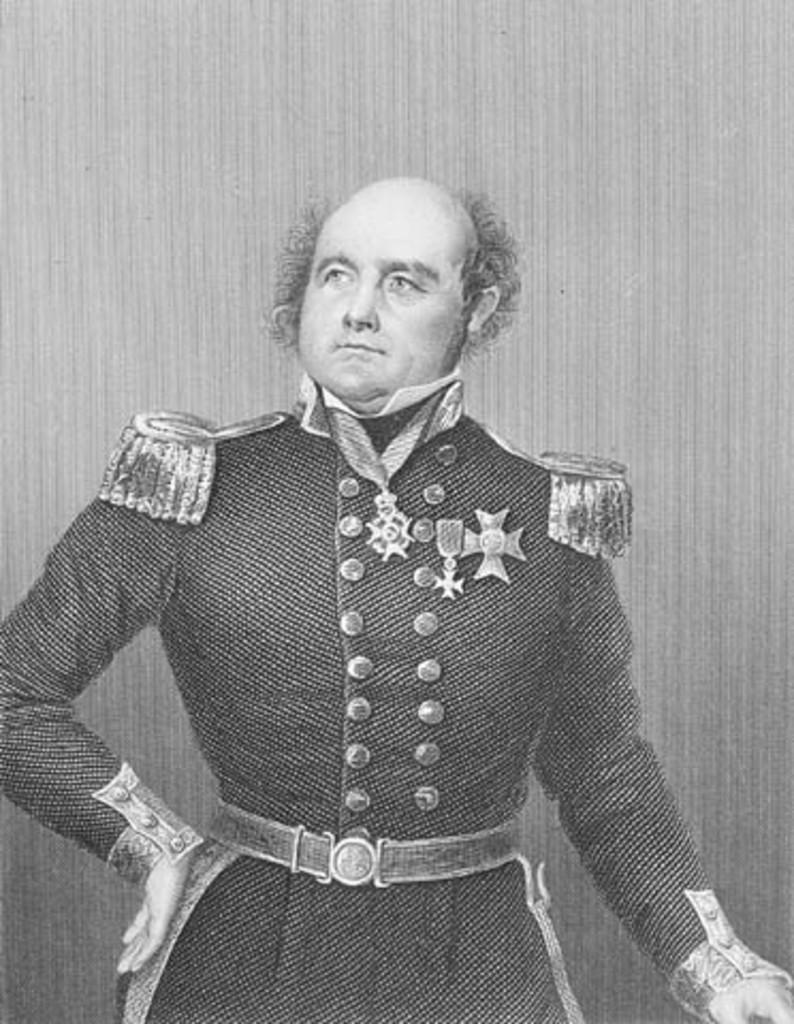Who is the main subject in the picture? There is a man in the picture. What is the man doing in the picture? The man is standing in front. What is the color scheme of the picture? The picture is black and white. What is the rate of the trains passing by in the picture? There are no trains present in the picture, so it is not possible to determine the rate at which they might be passing by. 